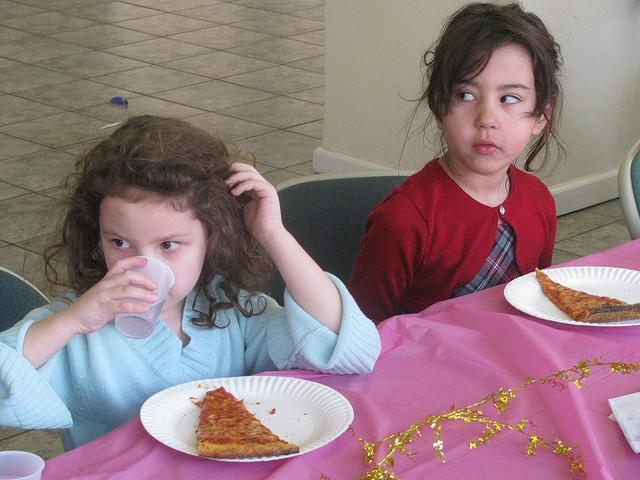How many people are wearing glasses?
Give a very brief answer. 0. How many pizzas are in the picture?
Give a very brief answer. 2. How many people are there?
Give a very brief answer. 2. 